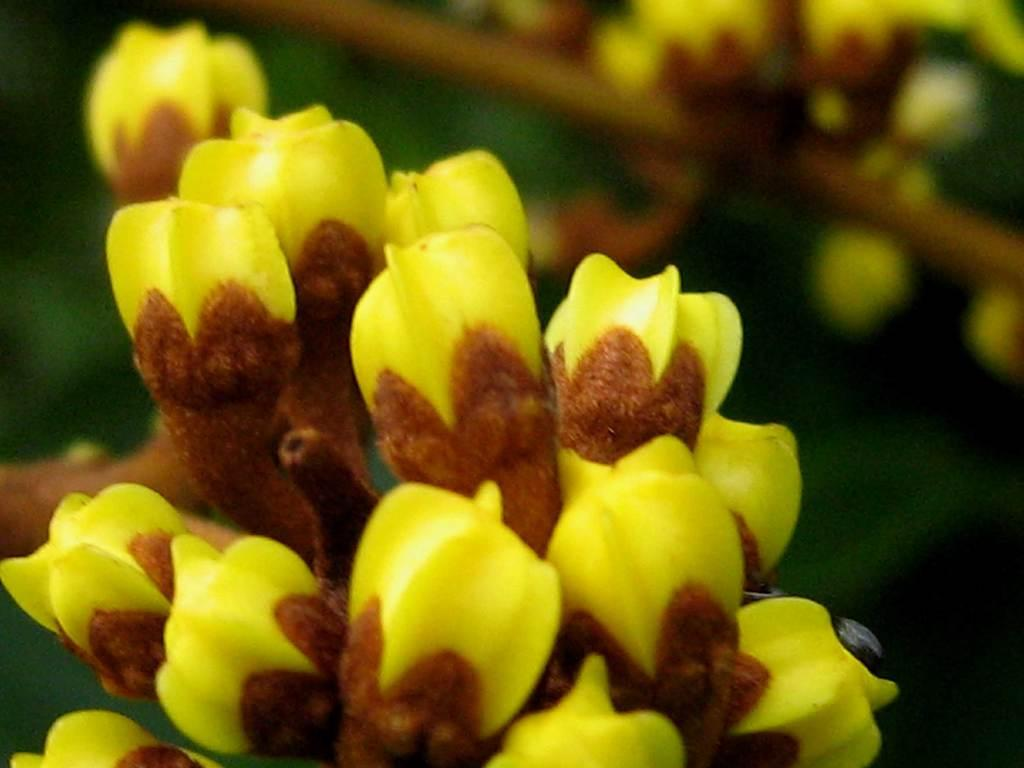What can be seen in the foreground of the image? There are some objects in the foreground of the image that resemble buds. What type of vegetation is visible in the background of the image? There are green leaves visible in the background of the image. Can you describe any other elements in the background of the image? There are other unspecified items in the background of the image. How many men are visible in the image? There are no men present in the image. What type of cars can be seen in the background of the image? There are no cars present in the image. 